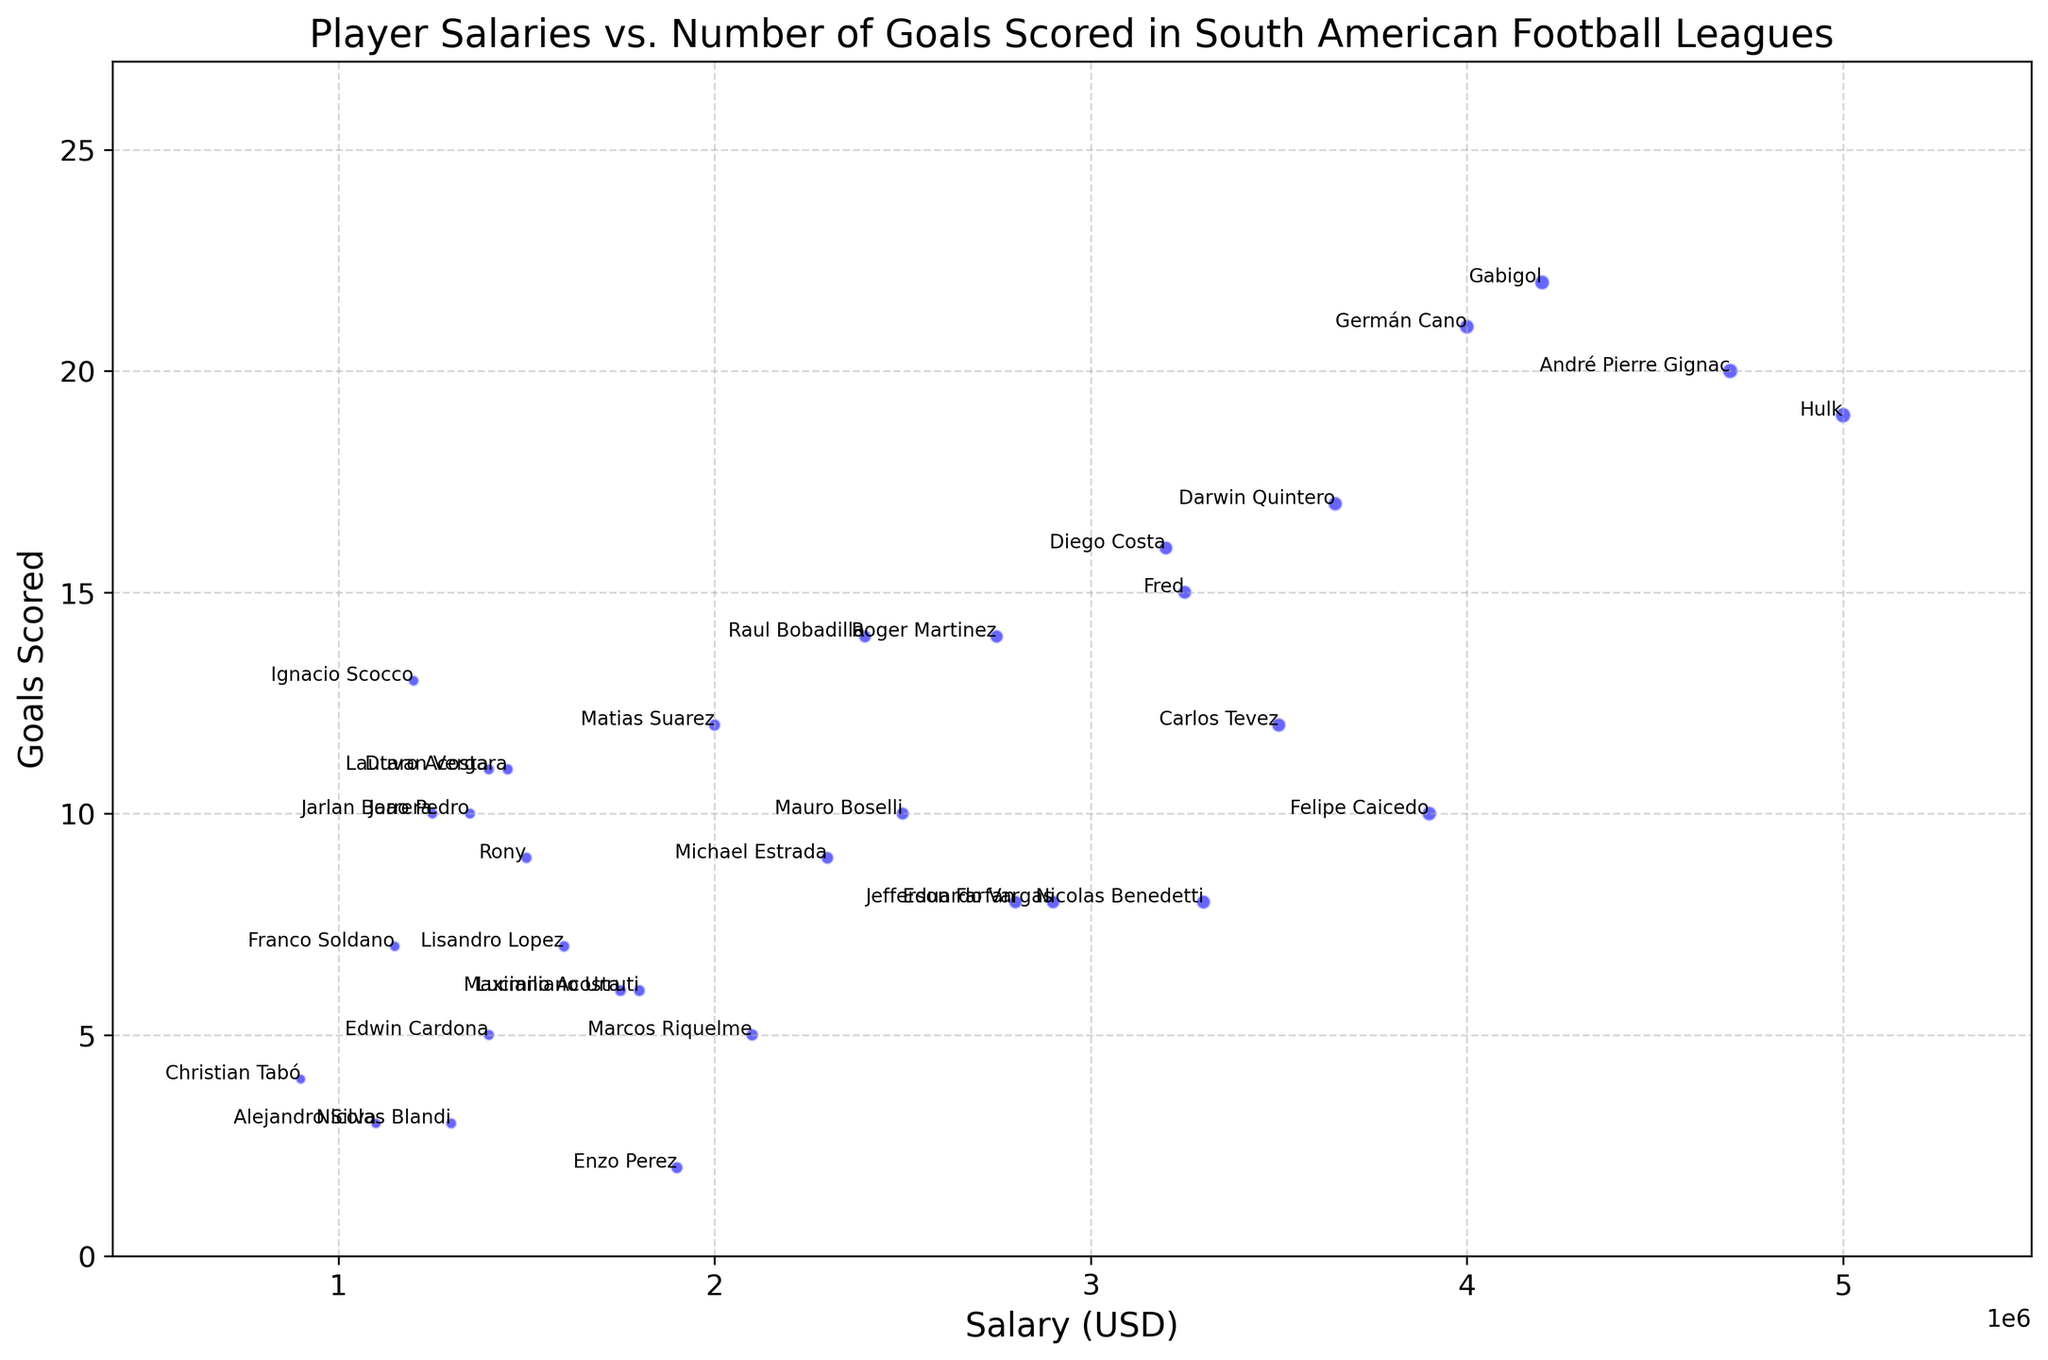What's the player with the highest salary? Look for the point with the highest x-coordinate, representing the highest salary. Based on our data, Hulk has the highest salary.
Answer: Hulk Who scored more goals, Hulk or Germán Cano? Compare the points labeled with Hulk and Germán Cano. Hulks's y-coordinate is 19, and Germán Cano's y-coordinate is 21.
Answer: Germán Cano Which player has the lowest salary but scored more than 10 goals? Search for the player with 10+ goals (y > 10) and the lowest x-coordinate among them. Ignacio Scocco has the lowest salary among the players who scored more than 10 goals.
Answer: Ignacio Scocco Is there a player who scored 11 goals and has a salary below USD 2,000,000? Identify the points with y = 11 and check their x-coordinates to be below USD 2,000,000. Lautaro Acosta and Duvan Vergara are such players.
Answer: Lautaro Acosta and Duvan Vergara What's the total number of goals scored by players earning more than USD 4,000,000? Find the points with x-coordinates > USD 4,000,000 and sum their y-coordinates. Gabigol (22), Hulk (19), Germán Cano (21), André Pierre Gignac (20), Darwin Quintero (17). Total: 22 + 19 + 21 + 20 + 17 = 99.
Answer: 99 Between Mauro Boselli and Roger Martinez, who has a higher salary, and by how much? Compare the x-coordinates of Mauro Boselli (USD 2,500,000) and Roger Martinez (USD 2,750,000). The difference is USD 2,750,000 - USD 2,500,000 = USD 250,000
Answer: Roger Martinez, by USD 250,000 What's the average salary of players who scored exactly 10 goals? Identify the players who scored exactly 10 goals: Mauro Boselli (USD 2,500,000), Joao Pedro (USD 1,350,000), Felipe Caicedo (USD 3,900,000), Jarlan Barrera (USD 1,250,000). Average: (USD 2,500,000 + USD 1,350,000 + USD 3,900,000 + USD 1,250,000) / 4 = USD 2,250,000
Answer: USD 2,250,000 Compare the densities of salary distributions for players scoring fewer than 10 goals and players scoring 10 or more goals visually. Check the clustered points below and above 10 goals. Fewer goal-scorers have more closely packed lower-salary points, while higher goal-scorers show a broader, sparser range.
Answer: Fewer goal-scorers have denser lower salaries Who has the highest goals-to-salary ratio among players earning more than USD 3,000,000? Calculate the ratio (Goals/Salary) for players earning above USD 3,000,000 and compare: Gabigol (22/4,200,000), Hulk (19/5,000,000), Diego Costa (16/3,200,000), Germán Cano (21/4,000,000), Fred (15/3,250,000), André Pierre Gignac (20/4,700,000), Felipe Caicedo (10/3,900,000), Darwin Quintero (17/3,650,000). The player with the highest ratio is Germán Cano (0.00525).
Answer: Germán Cano 